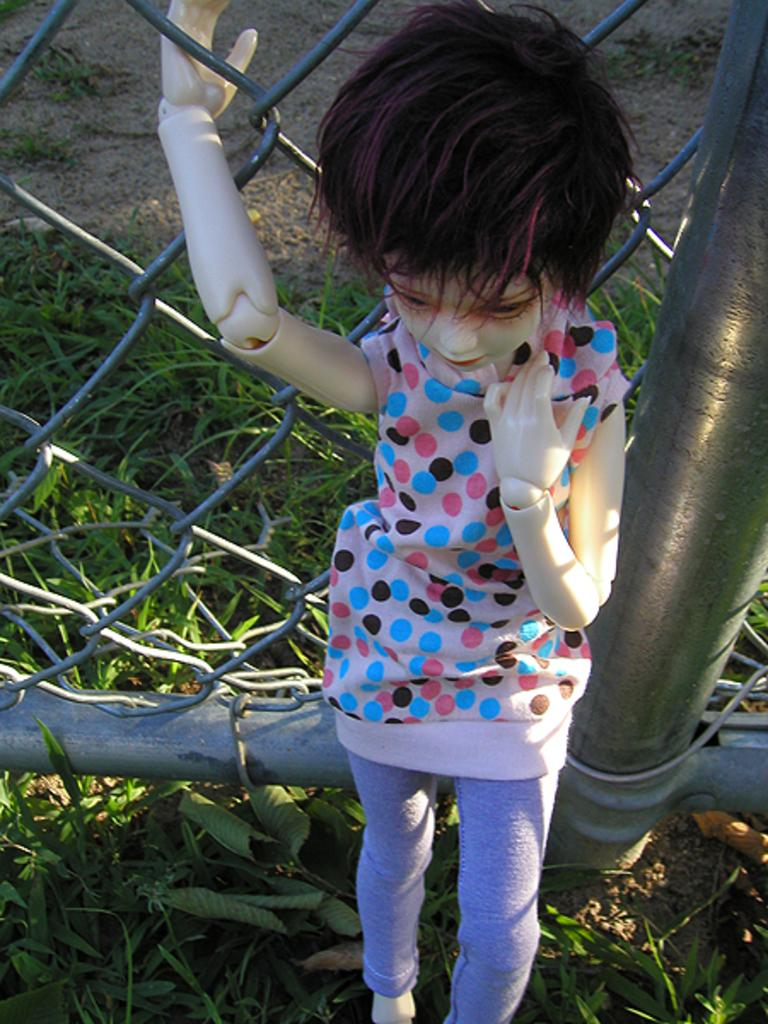What type of object is in the image? There is a toy person in the image. What is the toy person doing? The toy person is standing. What is the toy person wearing? The toy person is wearing a multi-color dress. What can be seen in the background of the image? There is railing visible in the background of the image, and the grass is green. What types of pets are visible in the image? There are no pets visible in the image; it features a toy person standing and wearing a multi-color dress. Are there any boats in the image? There are no boats present in the image. 